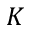<formula> <loc_0><loc_0><loc_500><loc_500>K</formula> 